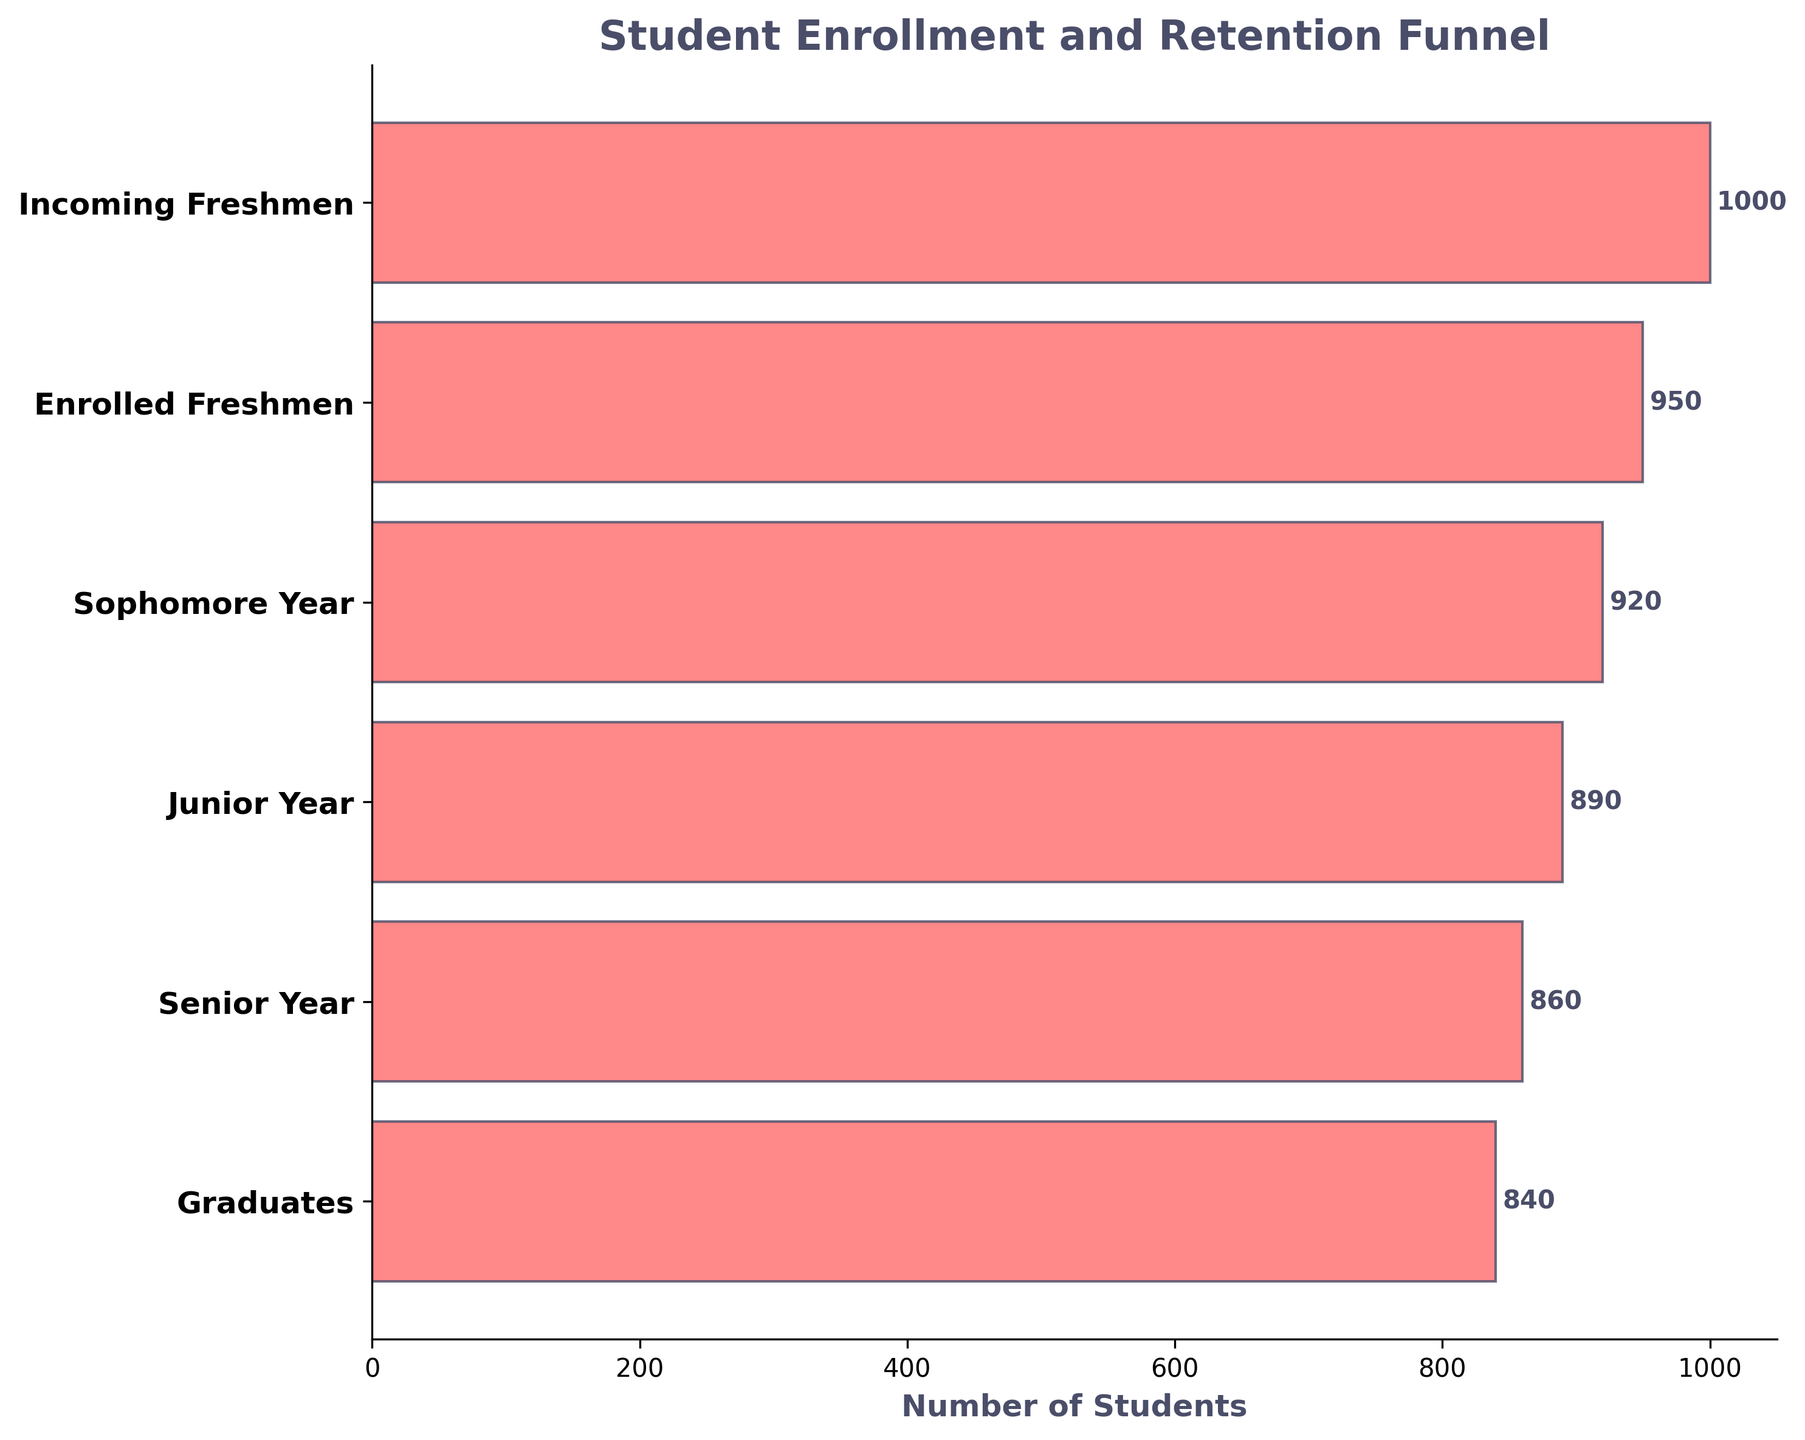What is the title of the plot? The title is prominently displayed at the top of the figure and indicates the main subject of the chart.
Answer: Student Enrollment and Retention Funnel How many stages are there in the funnel chart? Count the number of distinct stages listed on the vertical axis.
Answer: 6 How many students are there in the Incoming Freshmen stage? Refer to the number label on the bar corresponding to the Incoming Freshmen stage.
Answer: 1000 What is the difference in the number of students between the Incoming Freshmen and the Graduates stages? Subtract the number of students in the Graduates stage from those in the Incoming Freshmen stage: 1000 - 840.
Answer: 160 Which stage has the highest number of students? Identify the stage with the longest bar and the highest number label.
Answer: Incoming Freshmen Which stage has the lowest number of students? Identify the stage with the shortest bar and the lowest number label.
Answer: Graduates How many students are retained from the freshman year to the sophomore year? This asks for the number of students in the Sophomore Year stage.
Answer: 920 What is the retention rate from Incoming Freshmen to Enrolled Freshmen in percentage? Calculate the retention rate: (Enrolled Freshmen / Incoming Freshmen) * 100: (950 / 1000) * 100.
Answer: 95% What is the average number of students retained from Incoming Freshmen to Graduates? Sum the number of students in each stage from Incoming Freshmen to Graduates and divide by the number of stages: (1000 + 950 + 920 + 890 + 860 + 840) / 6.
Answer: 910 What is the retention rate from Junior Year to Senior Year? Calculate the retention rate: (Senior Year / Junior Year) * 100: (860 / 890) * 100.
Answer: 96.63% 